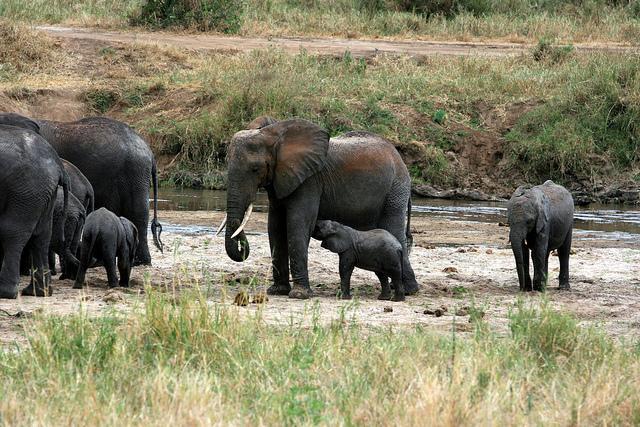How many baby elephants are in the photo?
Give a very brief answer. 3. How many elephants are in the photo?
Give a very brief answer. 6. How many people will fit in the smaller vehicle?
Give a very brief answer. 0. 